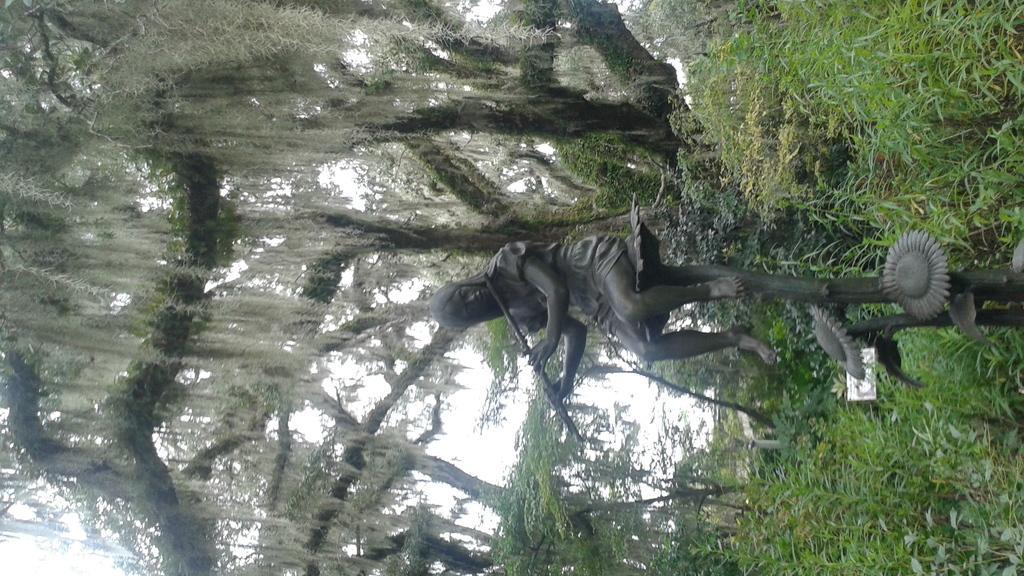How would you summarize this image in a sentence or two? In this image, we can see a statue. Background there is a blur view. Here we can see trees and sky. On the right side of the image, we can see plants and board. 